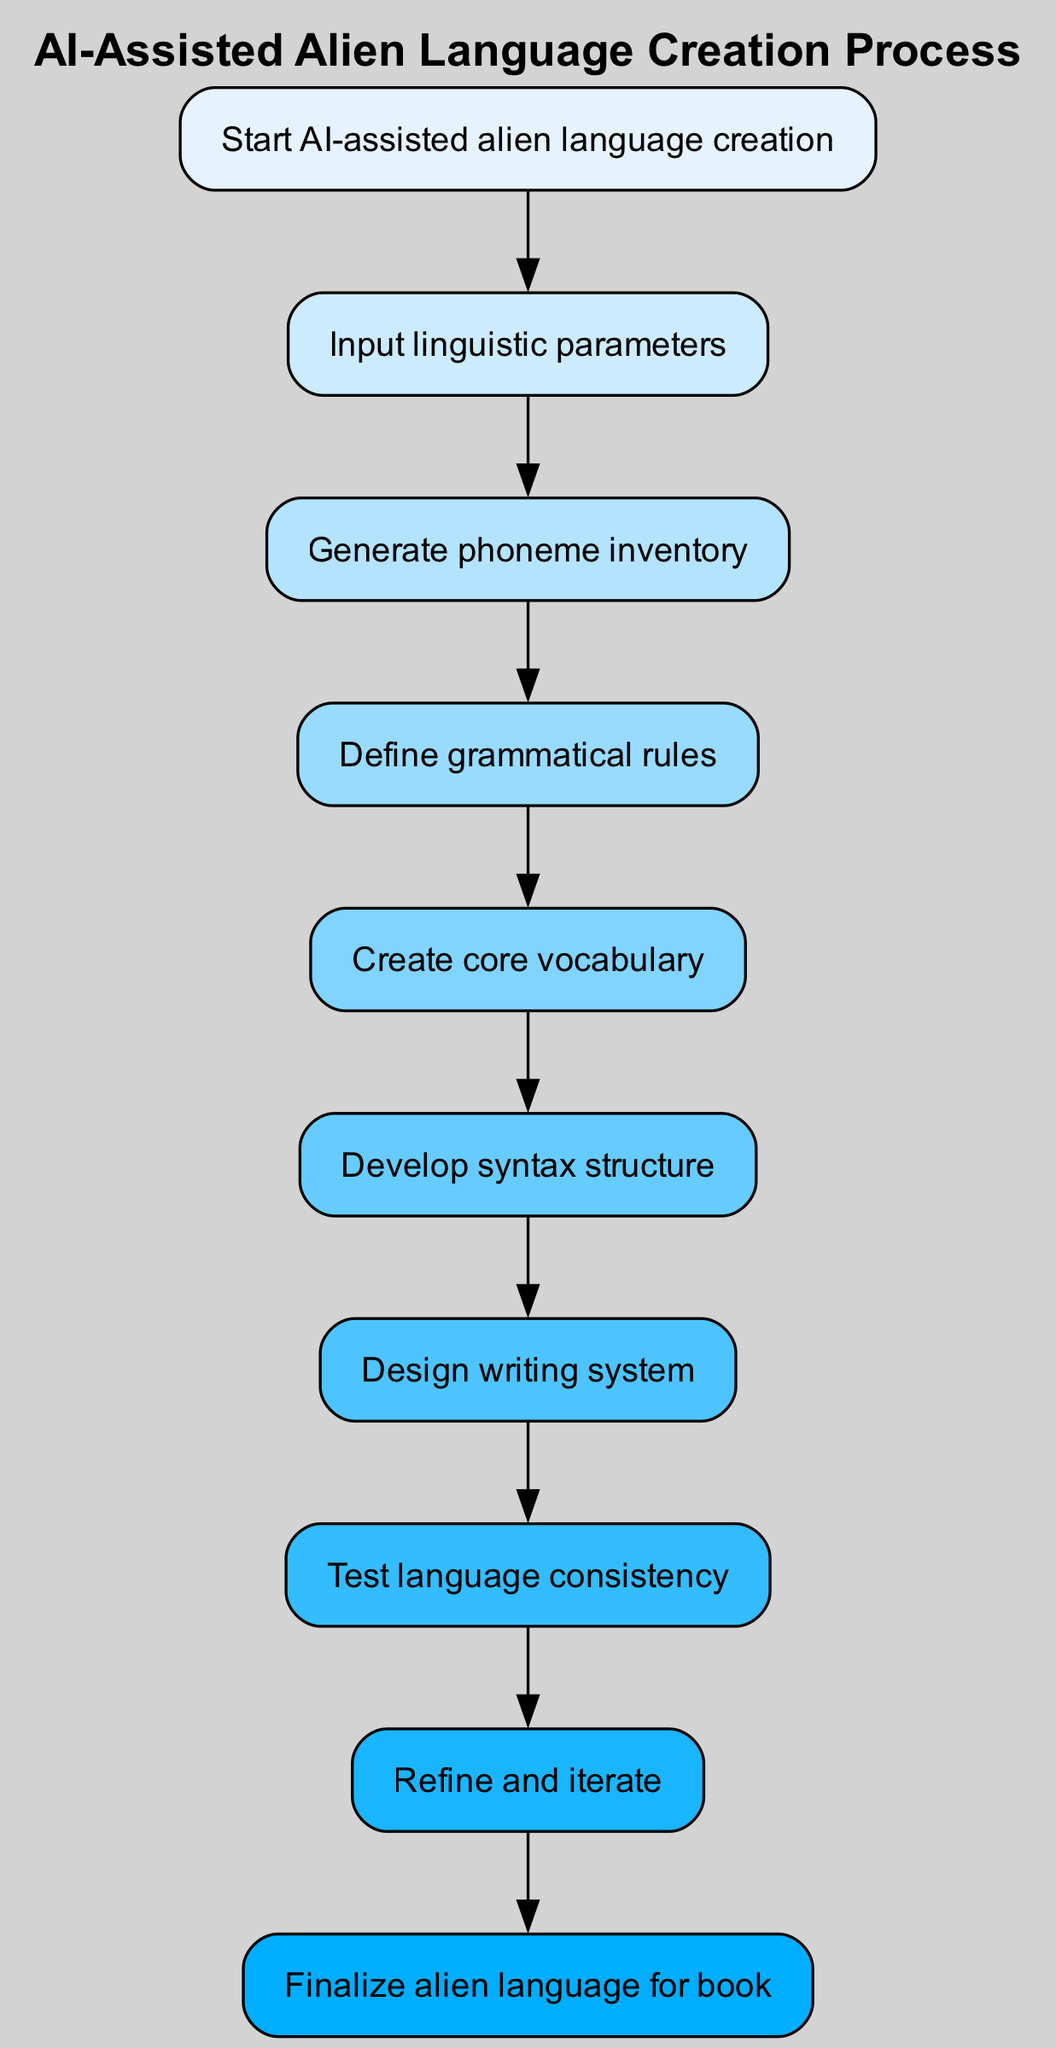What is the first step in the AI-assisted alien language creation process? The first step in the diagram is labeled "Start AI-assisted alien language creation," which signifies the initiation of the process.
Answer: Start AI-assisted alien language creation How many total steps are represented in the diagram? The diagram contains a total of 10 steps, counting both the start and end nodes along with the eight intermediary steps.
Answer: 10 What is the output of the input step? Upon reaching the input step, the next action is to "Input linguistic parameters," which indicates that the process requires specific details regarding the language characteristics before proceeding.
Answer: Input linguistic parameters Which step follows the vocabulary creation step? The vocabulary creation step leads directly to the "Develop syntax structure" step, showing that after establishing vocabulary, syntax development becomes the next focus.
Answer: Develop syntax structure What is the last action taken before finalizing the language? The last action before finalizing the alien language is "Refine and iterate," denoting a step for improvements and adjustments based on testing outcomes.
Answer: Refine and iterate Which node represents the step concerned with ensuring the language's rules are set? The step defining grammatical rules is represented by the "Define grammatical rules" node, which is essential for establishing the language's structure.
Answer: Define grammatical rules What is the relationship between the test and refine steps? The "Test language consistency" step directly leads to the "Refine and iterate" step, indicating that after testing, the language undergoes refinement.
Answer: Test language consistency to Refine and iterate How many edges are there connecting the steps in the diagram? There are 9 edges in total, each connecting one step to the next in a linear sequence through the process depicted in the flow chart.
Answer: 9 